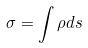<formula> <loc_0><loc_0><loc_500><loc_500>\sigma = \int \rho d s</formula> 